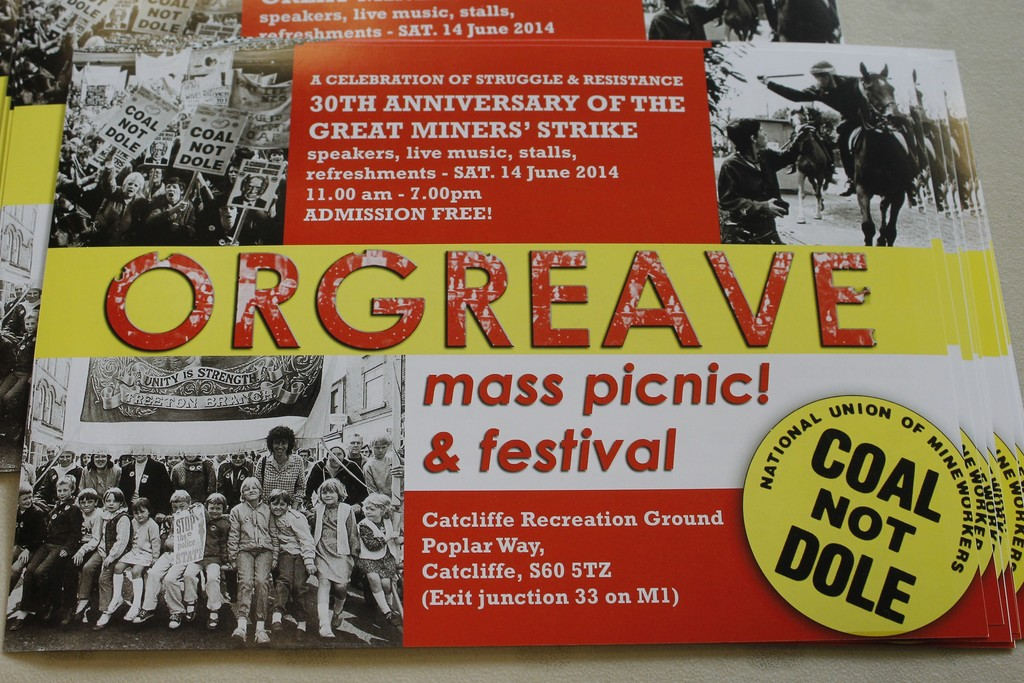What do you think is going on in this snapshot? This snapshot displays a poster promoting the 'Orgreave mass picnic & festival,' an event celebrating the 30th anniversary of the great miners' strike—a pivotal moment in labor history. Scheduled for June 14th at Catcliffe Recreation Ground, this event aims to reflect on the struggle and resistance of past labor movements. The festival features speeches, live music, and stalls, encapsulating a spirit of communal celebration and historical remembrance. Admission is free, making it accessible to a broad audience and ensuring that the legacy of unity and resistance remains vibrant and inclusive. 